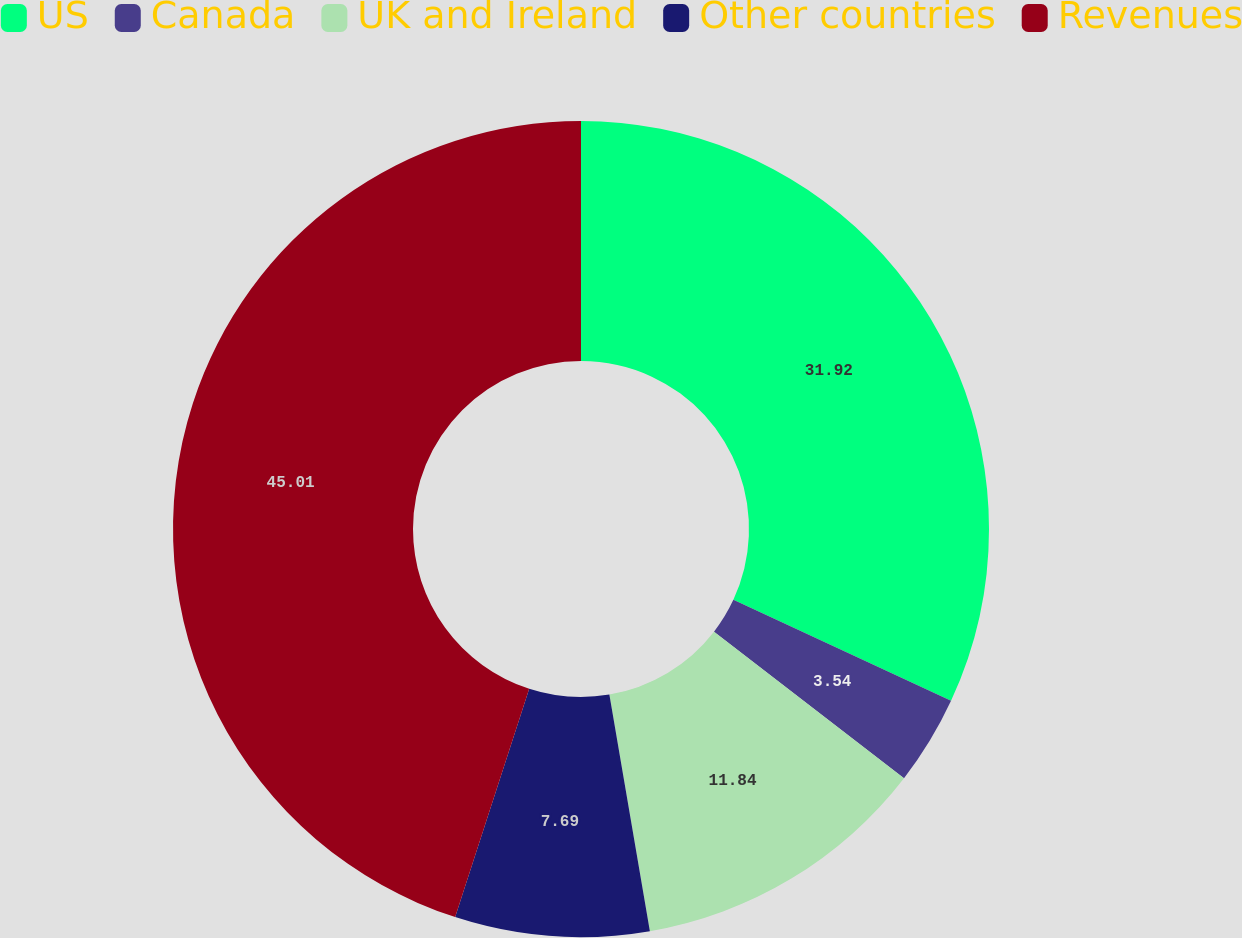Convert chart to OTSL. <chart><loc_0><loc_0><loc_500><loc_500><pie_chart><fcel>US<fcel>Canada<fcel>UK and Ireland<fcel>Other countries<fcel>Revenues<nl><fcel>31.92%<fcel>3.54%<fcel>11.84%<fcel>7.69%<fcel>45.01%<nl></chart> 